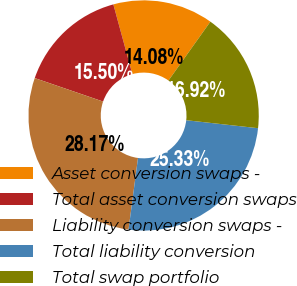Convert chart to OTSL. <chart><loc_0><loc_0><loc_500><loc_500><pie_chart><fcel>Asset conversion swaps -<fcel>Total asset conversion swaps<fcel>Liability conversion swaps -<fcel>Total liability conversion<fcel>Total swap portfolio<nl><fcel>14.08%<fcel>15.5%<fcel>28.17%<fcel>25.33%<fcel>16.92%<nl></chart> 